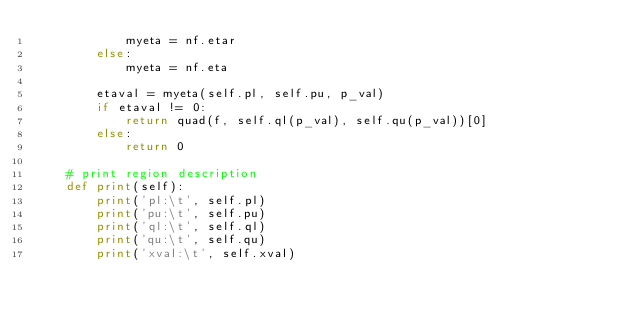<code> <loc_0><loc_0><loc_500><loc_500><_Python_>            myeta = nf.etar
        else:
            myeta = nf.eta

        etaval = myeta(self.pl, self.pu, p_val)
        if etaval != 0:
            return quad(f, self.ql(p_val), self.qu(p_val))[0]
        else:
            return 0

    # print region description
    def print(self):
        print('pl:\t', self.pl)
        print('pu:\t', self.pu)
        print('ql:\t', self.ql)
        print('qu:\t', self.qu)
        print('xval:\t', self.xval)

</code> 